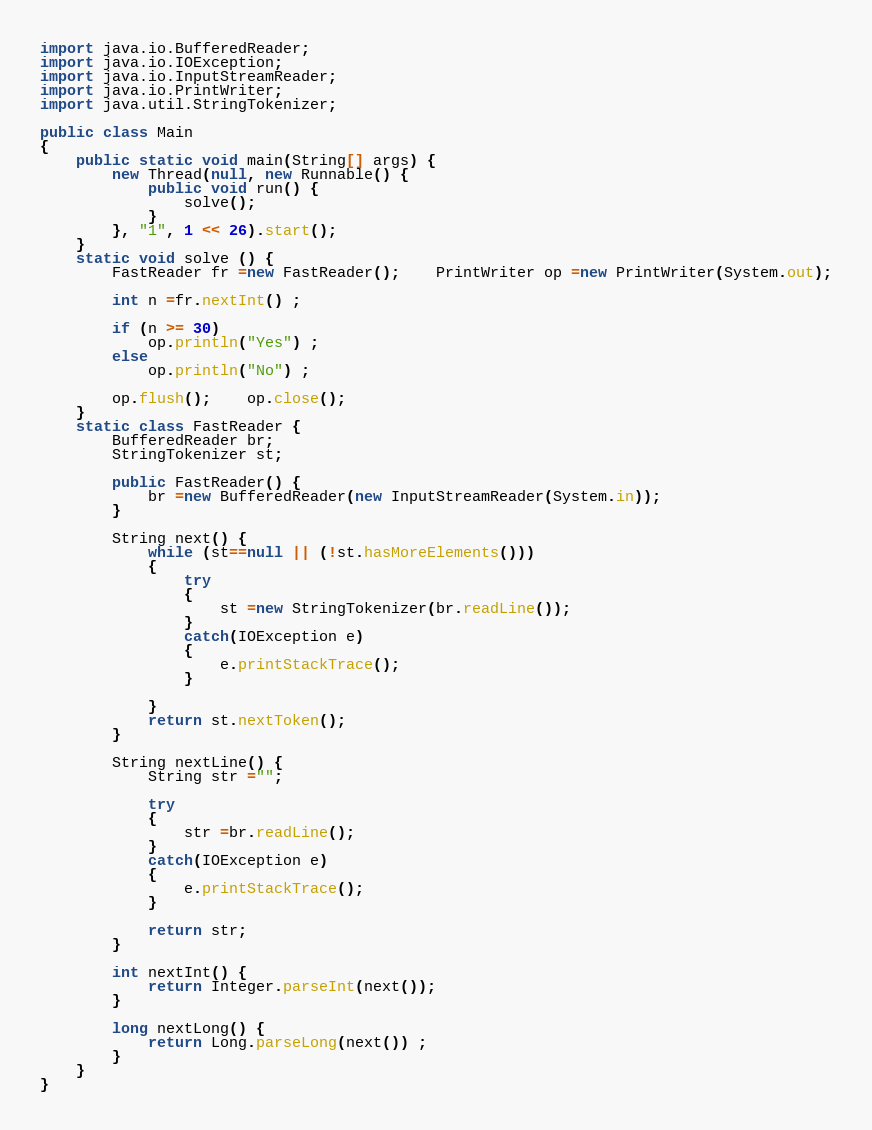Convert code to text. <code><loc_0><loc_0><loc_500><loc_500><_Java_>import java.io.BufferedReader;
import java.io.IOException;
import java.io.InputStreamReader;
import java.io.PrintWriter;
import java.util.StringTokenizer;

public class Main
{
	public static void main(String[] args) {
		new Thread(null, new Runnable() {
			public void run() {
                solve();
            }
        }, "1", 1 << 26).start();
	}
	static void solve () {
		FastReader fr =new FastReader();	PrintWriter op =new PrintWriter(System.out);
 
 		int n =fr.nextInt() ;

 		if (n >= 30)
 			op.println("Yes") ;
 		else 
 			op.println("No") ;

		op.flush();	op.close();
	}
	static class FastReader {
		BufferedReader br;
		StringTokenizer st;

		public FastReader() {
			br =new BufferedReader(new InputStreamReader(System.in));
		}

		String next() {
			while (st==null || (!st.hasMoreElements())) 
			{
				try
				{
					st =new StringTokenizer(br.readLine());
				}
				catch(IOException e)
				{
					e.printStackTrace();
				}
				
			}
			return st.nextToken();
		}

		String nextLine() {
			String str ="";

			try
			{
				str =br.readLine();
			}
			catch(IOException e)
			{
				e.printStackTrace();
			}

			return str;
		}

		int nextInt() {
			return Integer.parseInt(next());
		}

		long nextLong() {
			return Long.parseLong(next()) ;
		}
	}
}</code> 